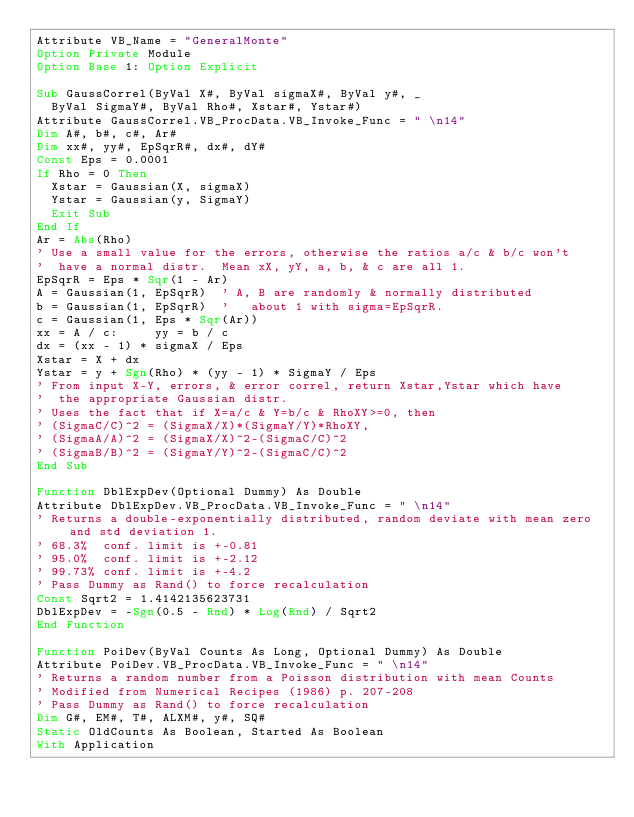Convert code to text. <code><loc_0><loc_0><loc_500><loc_500><_VisualBasic_>Attribute VB_Name = "GeneralMonte"
Option Private Module
Option Base 1: Option Explicit

Sub GaussCorrel(ByVal X#, ByVal sigmaX#, ByVal y#, _
  ByVal SigmaY#, ByVal Rho#, Xstar#, Ystar#)
Attribute GaussCorrel.VB_ProcData.VB_Invoke_Func = " \n14"
Dim A#, b#, c#, Ar#
Dim xx#, yy#, EpSqrR#, dx#, dY#
Const Eps = 0.0001
If Rho = 0 Then
  Xstar = Gaussian(X, sigmaX)
  Ystar = Gaussian(y, SigmaY)
  Exit Sub
End If
Ar = Abs(Rho)
' Use a small value for the errors, otherwise the ratios a/c & b/c won't
'  have a normal distr.  Mean xX, yY, a, b, & c are all 1.
EpSqrR = Eps * Sqr(1 - Ar)
A = Gaussian(1, EpSqrR)  ' A, B are randomly & normally distributed
b = Gaussian(1, EpSqrR)  '   about 1 with sigma=EpSqrR.
c = Gaussian(1, Eps * Sqr(Ar))
xx = A / c:     yy = b / c
dx = (xx - 1) * sigmaX / Eps
Xstar = X + dx
Ystar = y + Sgn(Rho) * (yy - 1) * SigmaY / Eps
' From input X-Y, errors, & error correl, return Xstar,Ystar which have
'  the appropriate Gaussian distr.
' Uses the fact that if X=a/c & Y=b/c & RhoXY>=0, then
' (SigmaC/C)^2 = (SigmaX/X)*(SigmaY/Y)*RhoXY,
' (SigmaA/A)^2 = (SigmaX/X)^2-(SigmaC/C)^2
' (SigmaB/B)^2 = (SigmaY/Y)^2-(SigmaC/C)^2
End Sub

Function DblExpDev(Optional Dummy) As Double
Attribute DblExpDev.VB_ProcData.VB_Invoke_Func = " \n14"
' Returns a double-exponentially distributed, random deviate with mean zero and std deviation 1.
' 68.3%  conf. limit is +-0.81
' 95.0%  conf. limit is +-2.12
' 99.73% conf. limit is +-4.2
' Pass Dummy as Rand() to force recalculation
Const Sqrt2 = 1.4142135623731
DblExpDev = -Sgn(0.5 - Rnd) * Log(Rnd) / Sqrt2
End Function

Function PoiDev(ByVal Counts As Long, Optional Dummy) As Double
Attribute PoiDev.VB_ProcData.VB_Invoke_Func = " \n14"
' Returns a random number from a Poisson distribution with mean Counts
' Modified from Numerical Recipes (1986) p. 207-208
' Pass Dummy as Rand() to force recalculation
Dim G#, EM#, T#, ALXM#, y#, SQ#
Static OldCounts As Boolean, Started As Boolean
With Application</code> 